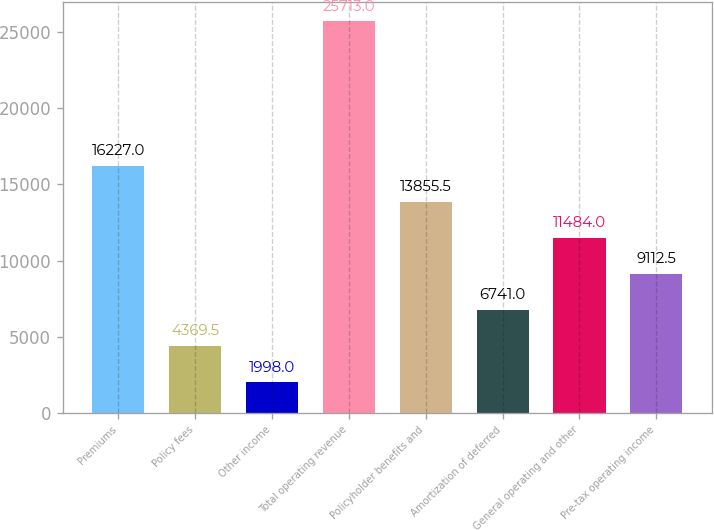Convert chart. <chart><loc_0><loc_0><loc_500><loc_500><bar_chart><fcel>Premiums<fcel>Policy fees<fcel>Other income<fcel>Total operating revenue<fcel>Policyholder benefits and<fcel>Amortization of deferred<fcel>General operating and other<fcel>Pre-tax operating income<nl><fcel>16227<fcel>4369.5<fcel>1998<fcel>25713<fcel>13855.5<fcel>6741<fcel>11484<fcel>9112.5<nl></chart> 